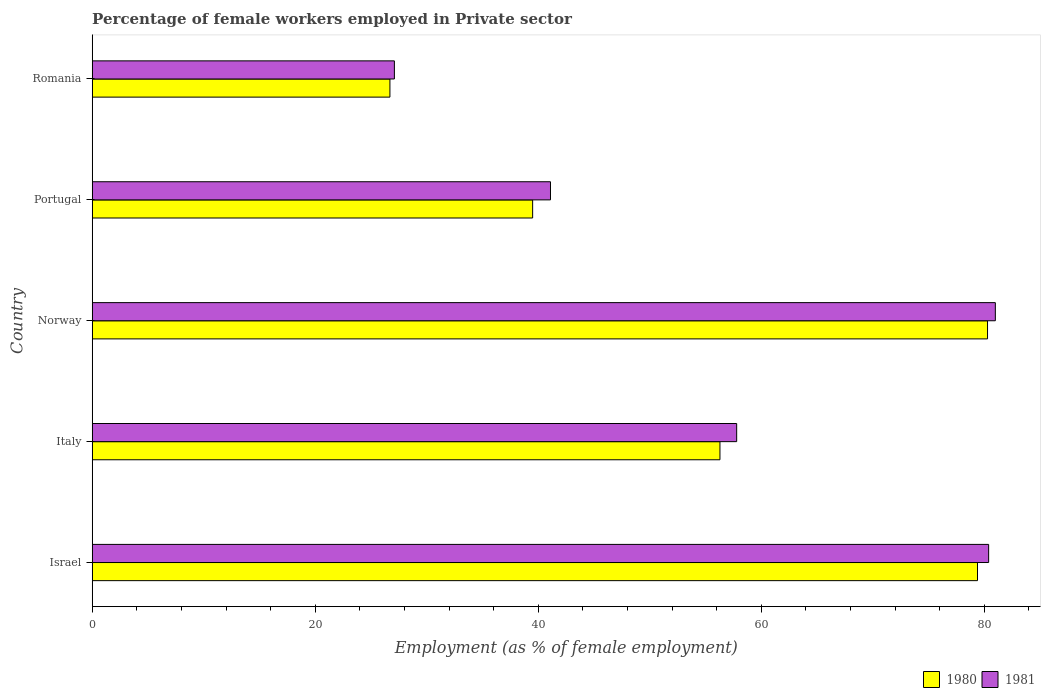How many different coloured bars are there?
Give a very brief answer. 2. Are the number of bars on each tick of the Y-axis equal?
Your answer should be very brief. Yes. How many bars are there on the 2nd tick from the top?
Ensure brevity in your answer.  2. What is the percentage of females employed in Private sector in 1981 in Romania?
Offer a very short reply. 27.1. Across all countries, what is the maximum percentage of females employed in Private sector in 1980?
Provide a short and direct response. 80.3. Across all countries, what is the minimum percentage of females employed in Private sector in 1981?
Give a very brief answer. 27.1. In which country was the percentage of females employed in Private sector in 1980 maximum?
Offer a very short reply. Norway. In which country was the percentage of females employed in Private sector in 1981 minimum?
Make the answer very short. Romania. What is the total percentage of females employed in Private sector in 1980 in the graph?
Offer a terse response. 282.2. What is the difference between the percentage of females employed in Private sector in 1980 in Israel and that in Italy?
Your response must be concise. 23.1. What is the difference between the percentage of females employed in Private sector in 1980 in Italy and the percentage of females employed in Private sector in 1981 in Norway?
Make the answer very short. -24.7. What is the average percentage of females employed in Private sector in 1981 per country?
Make the answer very short. 57.48. What is the difference between the percentage of females employed in Private sector in 1980 and percentage of females employed in Private sector in 1981 in Italy?
Keep it short and to the point. -1.5. In how many countries, is the percentage of females employed in Private sector in 1980 greater than 24 %?
Make the answer very short. 5. What is the ratio of the percentage of females employed in Private sector in 1981 in Italy to that in Romania?
Provide a short and direct response. 2.13. What is the difference between the highest and the second highest percentage of females employed in Private sector in 1980?
Keep it short and to the point. 0.9. What is the difference between the highest and the lowest percentage of females employed in Private sector in 1980?
Make the answer very short. 53.6. In how many countries, is the percentage of females employed in Private sector in 1981 greater than the average percentage of females employed in Private sector in 1981 taken over all countries?
Keep it short and to the point. 3. Is the sum of the percentage of females employed in Private sector in 1980 in Israel and Italy greater than the maximum percentage of females employed in Private sector in 1981 across all countries?
Give a very brief answer. Yes. What does the 1st bar from the bottom in Italy represents?
Offer a very short reply. 1980. How many bars are there?
Make the answer very short. 10. Are all the bars in the graph horizontal?
Ensure brevity in your answer.  Yes. Where does the legend appear in the graph?
Make the answer very short. Bottom right. How many legend labels are there?
Your response must be concise. 2. What is the title of the graph?
Give a very brief answer. Percentage of female workers employed in Private sector. What is the label or title of the X-axis?
Offer a terse response. Employment (as % of female employment). What is the label or title of the Y-axis?
Your answer should be very brief. Country. What is the Employment (as % of female employment) in 1980 in Israel?
Offer a terse response. 79.4. What is the Employment (as % of female employment) of 1981 in Israel?
Your answer should be compact. 80.4. What is the Employment (as % of female employment) in 1980 in Italy?
Your answer should be very brief. 56.3. What is the Employment (as % of female employment) of 1981 in Italy?
Make the answer very short. 57.8. What is the Employment (as % of female employment) of 1980 in Norway?
Make the answer very short. 80.3. What is the Employment (as % of female employment) of 1981 in Norway?
Your answer should be very brief. 81. What is the Employment (as % of female employment) of 1980 in Portugal?
Your answer should be very brief. 39.5. What is the Employment (as % of female employment) in 1981 in Portugal?
Make the answer very short. 41.1. What is the Employment (as % of female employment) of 1980 in Romania?
Make the answer very short. 26.7. What is the Employment (as % of female employment) of 1981 in Romania?
Offer a very short reply. 27.1. Across all countries, what is the maximum Employment (as % of female employment) of 1980?
Keep it short and to the point. 80.3. Across all countries, what is the minimum Employment (as % of female employment) of 1980?
Keep it short and to the point. 26.7. Across all countries, what is the minimum Employment (as % of female employment) in 1981?
Give a very brief answer. 27.1. What is the total Employment (as % of female employment) in 1980 in the graph?
Offer a terse response. 282.2. What is the total Employment (as % of female employment) in 1981 in the graph?
Give a very brief answer. 287.4. What is the difference between the Employment (as % of female employment) of 1980 in Israel and that in Italy?
Ensure brevity in your answer.  23.1. What is the difference between the Employment (as % of female employment) in 1981 in Israel and that in Italy?
Provide a succinct answer. 22.6. What is the difference between the Employment (as % of female employment) in 1981 in Israel and that in Norway?
Your answer should be very brief. -0.6. What is the difference between the Employment (as % of female employment) in 1980 in Israel and that in Portugal?
Keep it short and to the point. 39.9. What is the difference between the Employment (as % of female employment) in 1981 in Israel and that in Portugal?
Give a very brief answer. 39.3. What is the difference between the Employment (as % of female employment) in 1980 in Israel and that in Romania?
Ensure brevity in your answer.  52.7. What is the difference between the Employment (as % of female employment) of 1981 in Israel and that in Romania?
Your answer should be very brief. 53.3. What is the difference between the Employment (as % of female employment) in 1980 in Italy and that in Norway?
Offer a terse response. -24. What is the difference between the Employment (as % of female employment) in 1981 in Italy and that in Norway?
Ensure brevity in your answer.  -23.2. What is the difference between the Employment (as % of female employment) in 1981 in Italy and that in Portugal?
Provide a short and direct response. 16.7. What is the difference between the Employment (as % of female employment) in 1980 in Italy and that in Romania?
Ensure brevity in your answer.  29.6. What is the difference between the Employment (as % of female employment) of 1981 in Italy and that in Romania?
Your answer should be compact. 30.7. What is the difference between the Employment (as % of female employment) in 1980 in Norway and that in Portugal?
Your response must be concise. 40.8. What is the difference between the Employment (as % of female employment) in 1981 in Norway and that in Portugal?
Offer a very short reply. 39.9. What is the difference between the Employment (as % of female employment) of 1980 in Norway and that in Romania?
Provide a succinct answer. 53.6. What is the difference between the Employment (as % of female employment) in 1981 in Norway and that in Romania?
Keep it short and to the point. 53.9. What is the difference between the Employment (as % of female employment) in 1980 in Portugal and that in Romania?
Keep it short and to the point. 12.8. What is the difference between the Employment (as % of female employment) of 1981 in Portugal and that in Romania?
Keep it short and to the point. 14. What is the difference between the Employment (as % of female employment) in 1980 in Israel and the Employment (as % of female employment) in 1981 in Italy?
Give a very brief answer. 21.6. What is the difference between the Employment (as % of female employment) of 1980 in Israel and the Employment (as % of female employment) of 1981 in Norway?
Provide a short and direct response. -1.6. What is the difference between the Employment (as % of female employment) in 1980 in Israel and the Employment (as % of female employment) in 1981 in Portugal?
Ensure brevity in your answer.  38.3. What is the difference between the Employment (as % of female employment) of 1980 in Israel and the Employment (as % of female employment) of 1981 in Romania?
Offer a terse response. 52.3. What is the difference between the Employment (as % of female employment) in 1980 in Italy and the Employment (as % of female employment) in 1981 in Norway?
Provide a short and direct response. -24.7. What is the difference between the Employment (as % of female employment) of 1980 in Italy and the Employment (as % of female employment) of 1981 in Portugal?
Provide a short and direct response. 15.2. What is the difference between the Employment (as % of female employment) of 1980 in Italy and the Employment (as % of female employment) of 1981 in Romania?
Give a very brief answer. 29.2. What is the difference between the Employment (as % of female employment) of 1980 in Norway and the Employment (as % of female employment) of 1981 in Portugal?
Your answer should be very brief. 39.2. What is the difference between the Employment (as % of female employment) in 1980 in Norway and the Employment (as % of female employment) in 1981 in Romania?
Make the answer very short. 53.2. What is the average Employment (as % of female employment) of 1980 per country?
Offer a very short reply. 56.44. What is the average Employment (as % of female employment) in 1981 per country?
Make the answer very short. 57.48. What is the difference between the Employment (as % of female employment) of 1980 and Employment (as % of female employment) of 1981 in Israel?
Your answer should be compact. -1. What is the difference between the Employment (as % of female employment) of 1980 and Employment (as % of female employment) of 1981 in Italy?
Provide a succinct answer. -1.5. What is the difference between the Employment (as % of female employment) in 1980 and Employment (as % of female employment) in 1981 in Norway?
Offer a terse response. -0.7. What is the difference between the Employment (as % of female employment) of 1980 and Employment (as % of female employment) of 1981 in Romania?
Make the answer very short. -0.4. What is the ratio of the Employment (as % of female employment) of 1980 in Israel to that in Italy?
Your response must be concise. 1.41. What is the ratio of the Employment (as % of female employment) of 1981 in Israel to that in Italy?
Your answer should be compact. 1.39. What is the ratio of the Employment (as % of female employment) in 1980 in Israel to that in Portugal?
Your answer should be very brief. 2.01. What is the ratio of the Employment (as % of female employment) of 1981 in Israel to that in Portugal?
Your response must be concise. 1.96. What is the ratio of the Employment (as % of female employment) of 1980 in Israel to that in Romania?
Keep it short and to the point. 2.97. What is the ratio of the Employment (as % of female employment) in 1981 in Israel to that in Romania?
Make the answer very short. 2.97. What is the ratio of the Employment (as % of female employment) in 1980 in Italy to that in Norway?
Provide a short and direct response. 0.7. What is the ratio of the Employment (as % of female employment) of 1981 in Italy to that in Norway?
Your answer should be compact. 0.71. What is the ratio of the Employment (as % of female employment) of 1980 in Italy to that in Portugal?
Give a very brief answer. 1.43. What is the ratio of the Employment (as % of female employment) of 1981 in Italy to that in Portugal?
Offer a very short reply. 1.41. What is the ratio of the Employment (as % of female employment) of 1980 in Italy to that in Romania?
Give a very brief answer. 2.11. What is the ratio of the Employment (as % of female employment) in 1981 in Italy to that in Romania?
Make the answer very short. 2.13. What is the ratio of the Employment (as % of female employment) of 1980 in Norway to that in Portugal?
Offer a terse response. 2.03. What is the ratio of the Employment (as % of female employment) in 1981 in Norway to that in Portugal?
Give a very brief answer. 1.97. What is the ratio of the Employment (as % of female employment) of 1980 in Norway to that in Romania?
Keep it short and to the point. 3.01. What is the ratio of the Employment (as % of female employment) in 1981 in Norway to that in Romania?
Your response must be concise. 2.99. What is the ratio of the Employment (as % of female employment) in 1980 in Portugal to that in Romania?
Provide a short and direct response. 1.48. What is the ratio of the Employment (as % of female employment) in 1981 in Portugal to that in Romania?
Ensure brevity in your answer.  1.52. What is the difference between the highest and the second highest Employment (as % of female employment) of 1981?
Your answer should be very brief. 0.6. What is the difference between the highest and the lowest Employment (as % of female employment) in 1980?
Provide a succinct answer. 53.6. What is the difference between the highest and the lowest Employment (as % of female employment) of 1981?
Offer a terse response. 53.9. 